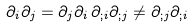<formula> <loc_0><loc_0><loc_500><loc_500>\partial _ { i } \partial _ { j } = \partial _ { j } \partial _ { i } \, \partial _ { ; i } \partial _ { ; j } \ne \partial _ { ; j } \partial _ { ; i }</formula> 